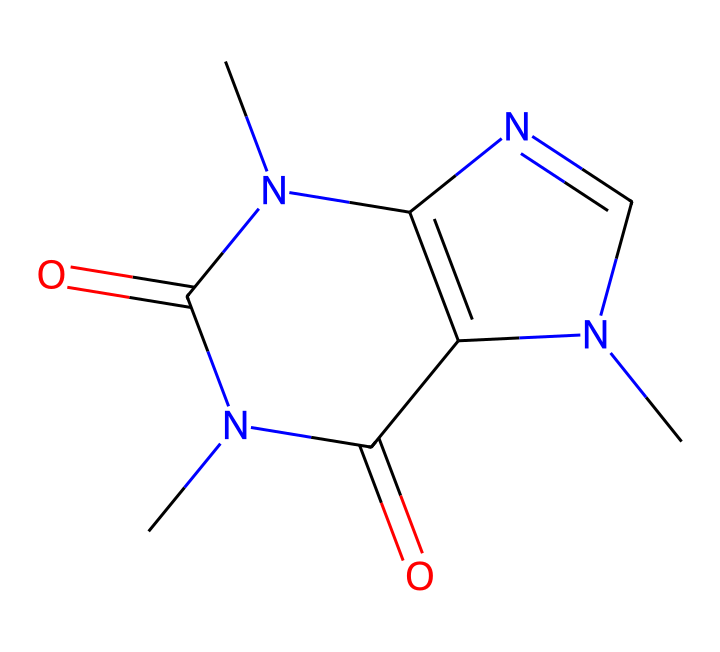What is the molecular formula of caffeine? To determine the molecular formula, count the number of each type of atom in the structure represented by the SMILES notation. The structure has 8 carbons (C), 10 hydrogens (H), 4 nitrogens (N), and 4 oxygens (O). Therefore, the molecular formula is C8H10N4O2.
Answer: C8H10N4O2 How many nitrogen atoms are present in caffeine? By examining the structure, we can identify each nitrogen atom. From the SMILES notation, we see that there are four nitrogen atoms shown by the 'N' present in the structure.
Answer: 4 Is caffeine a polar molecule or a non-polar molecule? To assess polarity, we consider the functional groups and overall structure. Since caffeine contains polar functional groups (like carbonyls and nitrogen), and has regions of electron density, it can interact with polar solvents such as water indicating it is a polar molecule.
Answer: polar Which component of the structure contributes to caffeine's stimulant properties? Caffeine's stimulant properties are generally attributed to its nitrogen atoms, which belong to a class of compounds known as xanthines. This class of compounds acts on the central nervous system by blocking adenosine receptors, enhancing alertness.
Answer: nitrogen atoms How many rings are present in the caffeine molecule? By analyzing the structure, we observe that caffeine consists of two fused rings, which can be identified in the SMILES notation where there are two sets of 'N' and 'C' indicating ring formations.
Answer: 2 Is caffeine classified as a non-electrolyte? Caffeine does not dissociate into ions when dissolved in water; therefore, it does not conduct electricity, which is the characteristic of non-electrolytes.
Answer: yes 